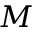<formula> <loc_0><loc_0><loc_500><loc_500>M</formula> 